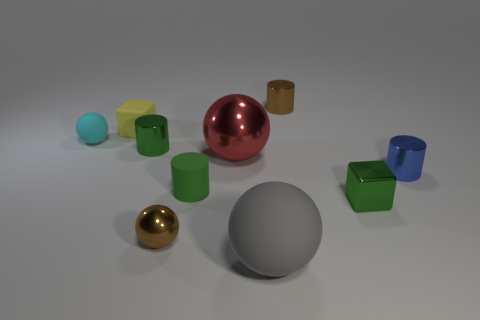Subtract all cylinders. How many objects are left? 6 Subtract 0 purple spheres. How many objects are left? 10 Subtract all tiny metallic cylinders. Subtract all tiny rubber spheres. How many objects are left? 6 Add 2 large rubber things. How many large rubber things are left? 3 Add 1 blue cylinders. How many blue cylinders exist? 2 